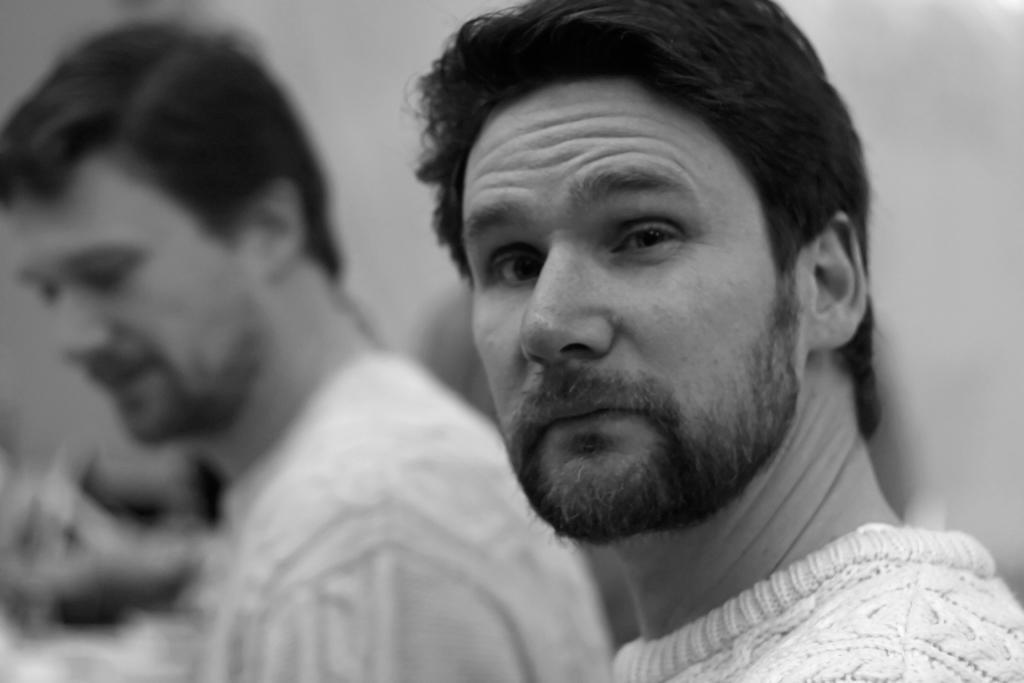Please provide a concise description of this image. On the left side of the image we can see a person, but he is in a blur. On the right side of the image we can see a person. 